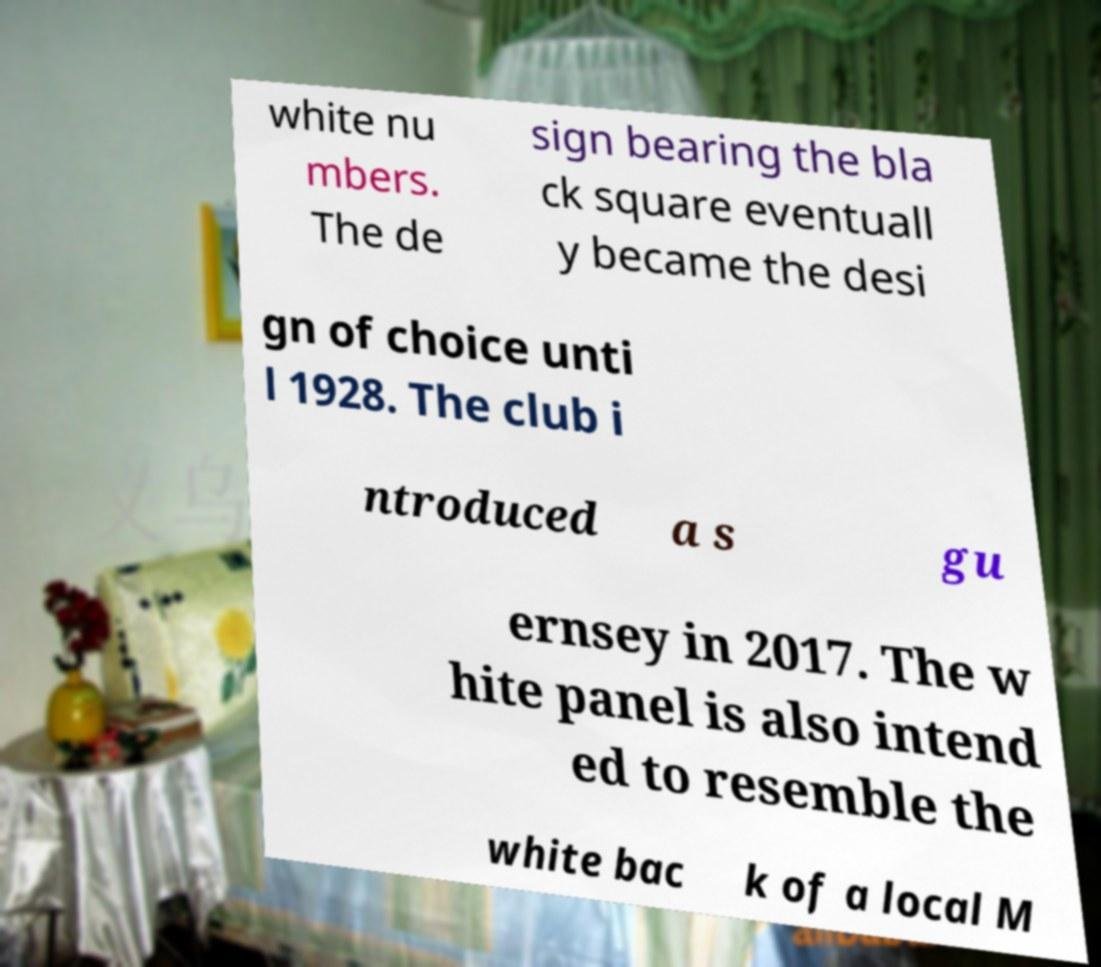Can you accurately transcribe the text from the provided image for me? white nu mbers. The de sign bearing the bla ck square eventuall y became the desi gn of choice unti l 1928. The club i ntroduced a s gu ernsey in 2017. The w hite panel is also intend ed to resemble the white bac k of a local M 